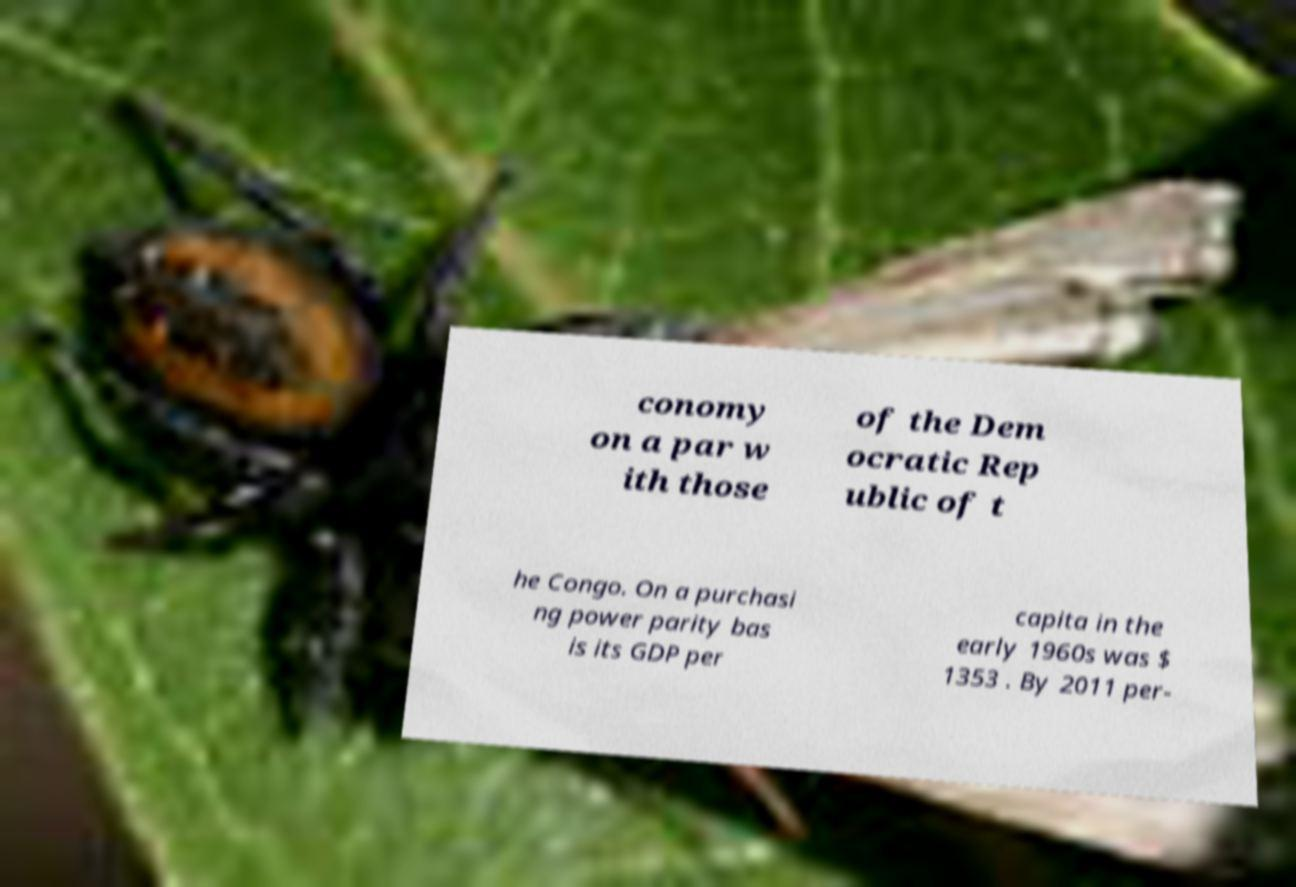For documentation purposes, I need the text within this image transcribed. Could you provide that? conomy on a par w ith those of the Dem ocratic Rep ublic of t he Congo. On a purchasi ng power parity bas is its GDP per capita in the early 1960s was $ 1353 . By 2011 per- 